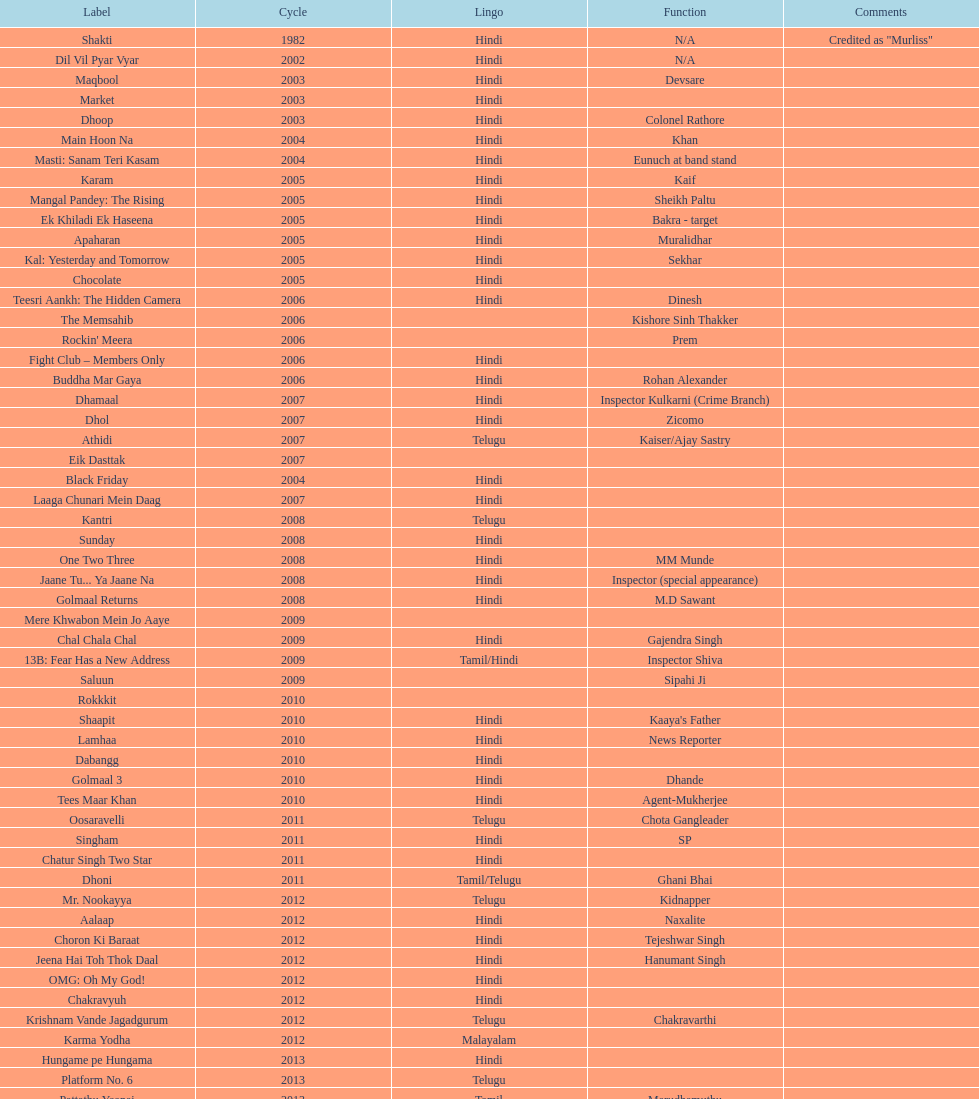What movie did this actor star in after they starred in dil vil pyar vyar in 2002? Maqbool. 